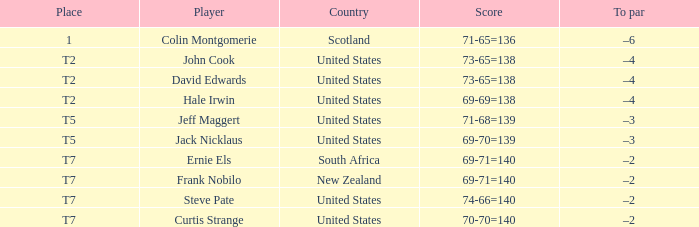In which country does frank nobilo participate as a player? New Zealand. 